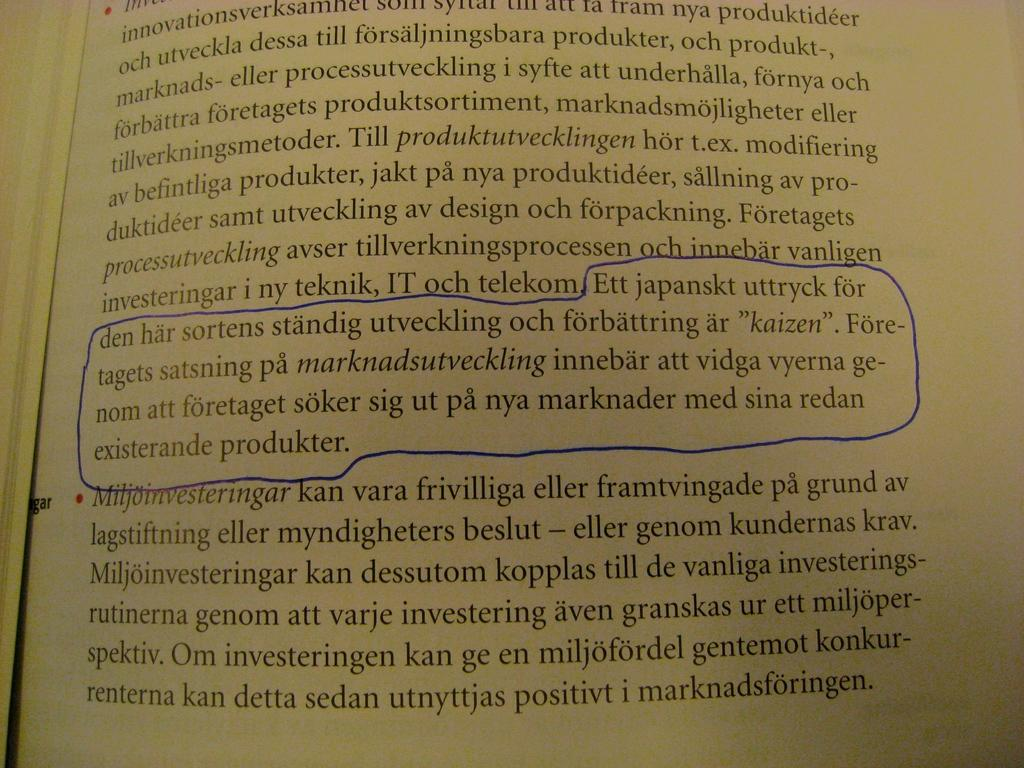Provide a one-sentence caption for the provided image. Ett Japanskt uttryck with a blue circle around it in a book. 